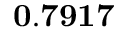Convert formula to latex. <formula><loc_0><loc_0><loc_500><loc_500>0 . 7 9 1 7</formula> 